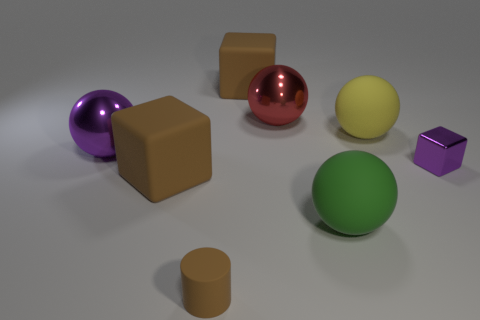Is there a large brown object made of the same material as the tiny brown cylinder?
Provide a short and direct response. Yes. What number of big metal things are the same shape as the big green rubber thing?
Offer a very short reply. 2. There is a purple thing right of the matte block to the right of the object in front of the big green rubber ball; what is its shape?
Offer a terse response. Cube. There is a cube that is in front of the big purple object and left of the large yellow ball; what material is it?
Your response must be concise. Rubber. Do the brown rubber object that is in front of the green object and the big green matte ball have the same size?
Offer a terse response. No. Are there any other things that have the same size as the red metal thing?
Keep it short and to the point. Yes. Is the number of brown rubber things that are right of the big green object greater than the number of cylinders that are behind the big red sphere?
Provide a succinct answer. No. There is a big shiny ball in front of the yellow thing that is right of the brown matte object left of the small cylinder; what color is it?
Ensure brevity in your answer.  Purple. Does the rubber cube that is behind the small shiny thing have the same color as the tiny cube?
Give a very brief answer. No. How many other objects are there of the same color as the matte cylinder?
Your answer should be compact. 2. 